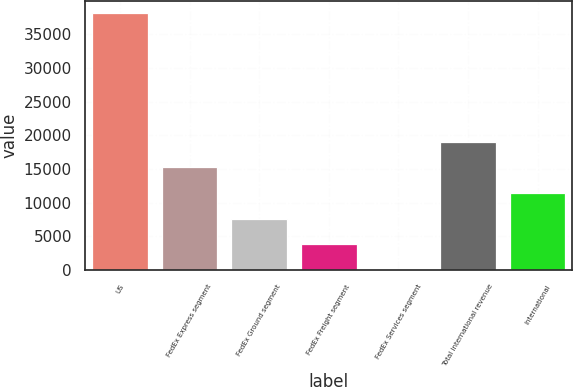Convert chart. <chart><loc_0><loc_0><loc_500><loc_500><bar_chart><fcel>US<fcel>FedEx Express segment<fcel>FedEx Ground segment<fcel>FedEx Freight segment<fcel>FedEx Services segment<fcel>Total international revenue<fcel>International<nl><fcel>38070<fcel>15234<fcel>7622<fcel>3816<fcel>10<fcel>19040<fcel>11428<nl></chart> 